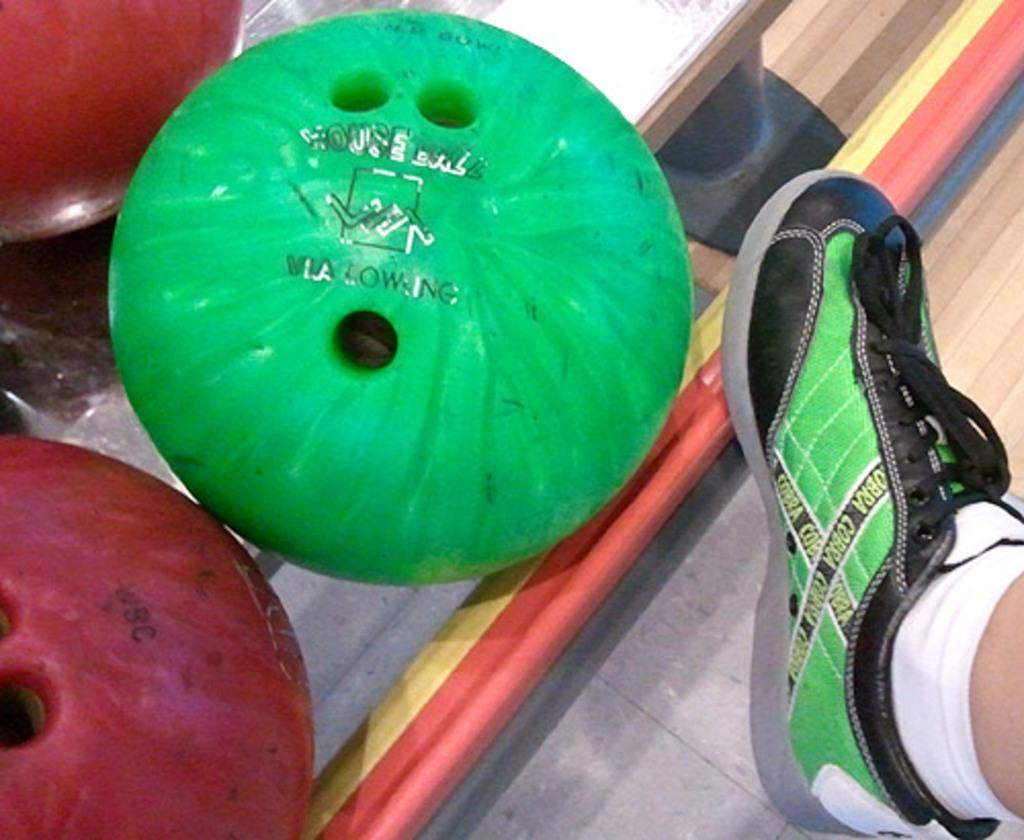What objects are present in the image? There are bowling balls in the image. Can you describe any other elements in the image? There is a person's leg on the right side of the image, and the floor is visible at the bottom of the image. What is the name of the person's daughter who is not present in the image? There is no information about a daughter in the image, so it is not possible to answer that question. 